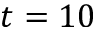<formula> <loc_0><loc_0><loc_500><loc_500>t = 1 0</formula> 